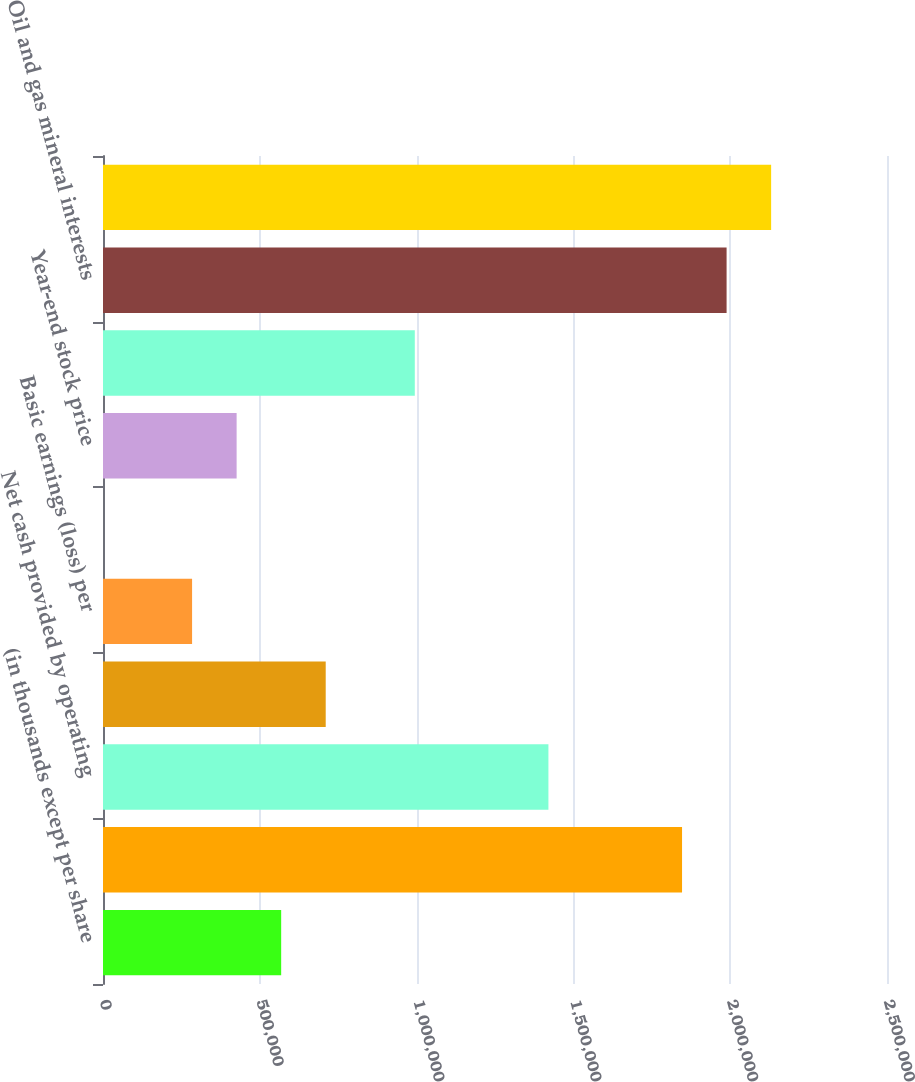Convert chart. <chart><loc_0><loc_0><loc_500><loc_500><bar_chart><fcel>(in thousands except per share<fcel>Revenues<fcel>Net cash provided by operating<fcel>Net income (loss)<fcel>Basic earnings (loss) per<fcel>Cash dividends<fcel>Year-end stock price<fcel>Basic weighted average shares<fcel>Oil and gas mineral interests<fcel>Total assets<nl><fcel>568140<fcel>1.84646e+06<fcel>1.42035e+06<fcel>710176<fcel>284070<fcel>0.16<fcel>426105<fcel>994246<fcel>1.98849e+06<fcel>2.13053e+06<nl></chart> 